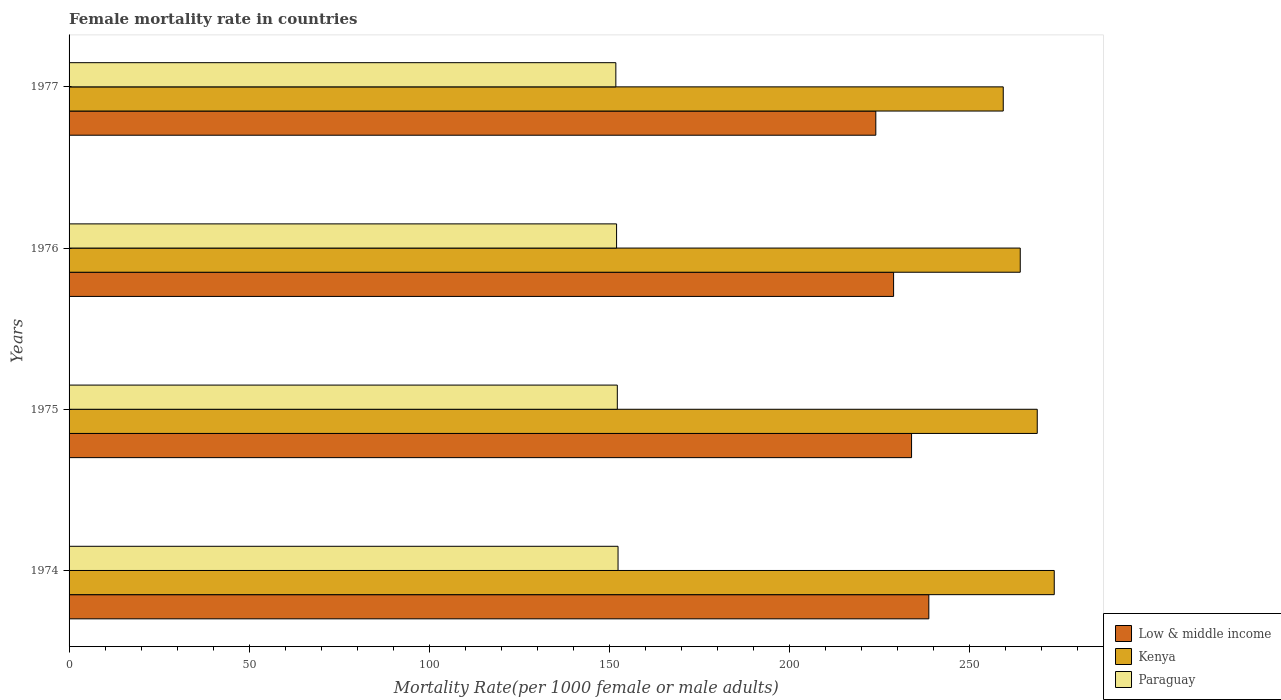How many groups of bars are there?
Offer a very short reply. 4. Are the number of bars on each tick of the Y-axis equal?
Offer a very short reply. Yes. What is the label of the 2nd group of bars from the top?
Offer a terse response. 1976. What is the female mortality rate in Paraguay in 1976?
Provide a succinct answer. 152.01. Across all years, what is the maximum female mortality rate in Paraguay?
Keep it short and to the point. 152.42. Across all years, what is the minimum female mortality rate in Kenya?
Your answer should be very brief. 259.36. In which year was the female mortality rate in Paraguay maximum?
Your response must be concise. 1974. What is the total female mortality rate in Kenya in the graph?
Ensure brevity in your answer.  1065.75. What is the difference between the female mortality rate in Low & middle income in 1976 and that in 1977?
Make the answer very short. 4.94. What is the difference between the female mortality rate in Paraguay in 1977 and the female mortality rate in Low & middle income in 1974?
Offer a very short reply. -86.89. What is the average female mortality rate in Paraguay per year?
Keep it short and to the point. 152.11. In the year 1977, what is the difference between the female mortality rate in Kenya and female mortality rate in Low & middle income?
Offer a very short reply. 35.38. In how many years, is the female mortality rate in Kenya greater than 90 ?
Provide a short and direct response. 4. What is the ratio of the female mortality rate in Low & middle income in 1976 to that in 1977?
Your response must be concise. 1.02. Is the difference between the female mortality rate in Kenya in 1974 and 1977 greater than the difference between the female mortality rate in Low & middle income in 1974 and 1977?
Provide a succinct answer. No. What is the difference between the highest and the second highest female mortality rate in Paraguay?
Offer a very short reply. 0.2. What is the difference between the highest and the lowest female mortality rate in Kenya?
Keep it short and to the point. 14.16. In how many years, is the female mortality rate in Low & middle income greater than the average female mortality rate in Low & middle income taken over all years?
Give a very brief answer. 2. Is the sum of the female mortality rate in Paraguay in 1974 and 1977 greater than the maximum female mortality rate in Low & middle income across all years?
Your answer should be compact. Yes. What does the 1st bar from the top in 1974 represents?
Keep it short and to the point. Paraguay. What does the 2nd bar from the bottom in 1975 represents?
Provide a succinct answer. Kenya. Is it the case that in every year, the sum of the female mortality rate in Low & middle income and female mortality rate in Kenya is greater than the female mortality rate in Paraguay?
Make the answer very short. Yes. How many years are there in the graph?
Ensure brevity in your answer.  4. Are the values on the major ticks of X-axis written in scientific E-notation?
Ensure brevity in your answer.  No. Does the graph contain any zero values?
Make the answer very short. No. Does the graph contain grids?
Keep it short and to the point. No. Where does the legend appear in the graph?
Your answer should be compact. Bottom right. How many legend labels are there?
Your answer should be very brief. 3. What is the title of the graph?
Your response must be concise. Female mortality rate in countries. Does "Curacao" appear as one of the legend labels in the graph?
Provide a succinct answer. No. What is the label or title of the X-axis?
Your answer should be very brief. Mortality Rate(per 1000 female or male adults). What is the label or title of the Y-axis?
Make the answer very short. Years. What is the Mortality Rate(per 1000 female or male adults) in Low & middle income in 1974?
Give a very brief answer. 238.7. What is the Mortality Rate(per 1000 female or male adults) of Kenya in 1974?
Ensure brevity in your answer.  273.52. What is the Mortality Rate(per 1000 female or male adults) in Paraguay in 1974?
Give a very brief answer. 152.42. What is the Mortality Rate(per 1000 female or male adults) of Low & middle income in 1975?
Offer a very short reply. 233.9. What is the Mortality Rate(per 1000 female or male adults) in Kenya in 1975?
Offer a very short reply. 268.8. What is the Mortality Rate(per 1000 female or male adults) in Paraguay in 1975?
Your response must be concise. 152.21. What is the Mortality Rate(per 1000 female or male adults) of Low & middle income in 1976?
Your answer should be compact. 228.92. What is the Mortality Rate(per 1000 female or male adults) of Kenya in 1976?
Provide a succinct answer. 264.08. What is the Mortality Rate(per 1000 female or male adults) in Paraguay in 1976?
Your answer should be very brief. 152.01. What is the Mortality Rate(per 1000 female or male adults) in Low & middle income in 1977?
Your answer should be very brief. 223.98. What is the Mortality Rate(per 1000 female or male adults) of Kenya in 1977?
Offer a very short reply. 259.36. What is the Mortality Rate(per 1000 female or male adults) of Paraguay in 1977?
Offer a very short reply. 151.8. Across all years, what is the maximum Mortality Rate(per 1000 female or male adults) in Low & middle income?
Make the answer very short. 238.7. Across all years, what is the maximum Mortality Rate(per 1000 female or male adults) in Kenya?
Provide a short and direct response. 273.52. Across all years, what is the maximum Mortality Rate(per 1000 female or male adults) in Paraguay?
Keep it short and to the point. 152.42. Across all years, what is the minimum Mortality Rate(per 1000 female or male adults) in Low & middle income?
Your answer should be very brief. 223.98. Across all years, what is the minimum Mortality Rate(per 1000 female or male adults) of Kenya?
Your answer should be very brief. 259.36. Across all years, what is the minimum Mortality Rate(per 1000 female or male adults) in Paraguay?
Offer a terse response. 151.8. What is the total Mortality Rate(per 1000 female or male adults) of Low & middle income in the graph?
Your answer should be compact. 925.49. What is the total Mortality Rate(per 1000 female or male adults) in Kenya in the graph?
Your answer should be compact. 1065.75. What is the total Mortality Rate(per 1000 female or male adults) of Paraguay in the graph?
Give a very brief answer. 608.44. What is the difference between the Mortality Rate(per 1000 female or male adults) in Low & middle income in 1974 and that in 1975?
Provide a succinct answer. 4.8. What is the difference between the Mortality Rate(per 1000 female or male adults) of Kenya in 1974 and that in 1975?
Ensure brevity in your answer.  4.72. What is the difference between the Mortality Rate(per 1000 female or male adults) of Paraguay in 1974 and that in 1975?
Keep it short and to the point. 0.2. What is the difference between the Mortality Rate(per 1000 female or male adults) in Low & middle income in 1974 and that in 1976?
Give a very brief answer. 9.78. What is the difference between the Mortality Rate(per 1000 female or male adults) of Kenya in 1974 and that in 1976?
Your answer should be very brief. 9.44. What is the difference between the Mortality Rate(per 1000 female or male adults) of Paraguay in 1974 and that in 1976?
Your answer should be very brief. 0.41. What is the difference between the Mortality Rate(per 1000 female or male adults) in Low & middle income in 1974 and that in 1977?
Provide a short and direct response. 14.72. What is the difference between the Mortality Rate(per 1000 female or male adults) of Kenya in 1974 and that in 1977?
Provide a succinct answer. 14.16. What is the difference between the Mortality Rate(per 1000 female or male adults) of Paraguay in 1974 and that in 1977?
Your answer should be very brief. 0.61. What is the difference between the Mortality Rate(per 1000 female or male adults) in Low & middle income in 1975 and that in 1976?
Give a very brief answer. 4.99. What is the difference between the Mortality Rate(per 1000 female or male adults) of Kenya in 1975 and that in 1976?
Offer a terse response. 4.72. What is the difference between the Mortality Rate(per 1000 female or male adults) of Paraguay in 1975 and that in 1976?
Offer a very short reply. 0.2. What is the difference between the Mortality Rate(per 1000 female or male adults) in Low & middle income in 1975 and that in 1977?
Keep it short and to the point. 9.93. What is the difference between the Mortality Rate(per 1000 female or male adults) of Kenya in 1975 and that in 1977?
Provide a short and direct response. 9.44. What is the difference between the Mortality Rate(per 1000 female or male adults) of Paraguay in 1975 and that in 1977?
Offer a terse response. 0.41. What is the difference between the Mortality Rate(per 1000 female or male adults) in Low & middle income in 1976 and that in 1977?
Ensure brevity in your answer.  4.94. What is the difference between the Mortality Rate(per 1000 female or male adults) in Kenya in 1976 and that in 1977?
Give a very brief answer. 4.72. What is the difference between the Mortality Rate(per 1000 female or male adults) of Paraguay in 1976 and that in 1977?
Offer a terse response. 0.2. What is the difference between the Mortality Rate(per 1000 female or male adults) of Low & middle income in 1974 and the Mortality Rate(per 1000 female or male adults) of Kenya in 1975?
Your answer should be compact. -30.1. What is the difference between the Mortality Rate(per 1000 female or male adults) of Low & middle income in 1974 and the Mortality Rate(per 1000 female or male adults) of Paraguay in 1975?
Ensure brevity in your answer.  86.49. What is the difference between the Mortality Rate(per 1000 female or male adults) in Kenya in 1974 and the Mortality Rate(per 1000 female or male adults) in Paraguay in 1975?
Provide a short and direct response. 121.31. What is the difference between the Mortality Rate(per 1000 female or male adults) in Low & middle income in 1974 and the Mortality Rate(per 1000 female or male adults) in Kenya in 1976?
Give a very brief answer. -25.38. What is the difference between the Mortality Rate(per 1000 female or male adults) of Low & middle income in 1974 and the Mortality Rate(per 1000 female or male adults) of Paraguay in 1976?
Offer a very short reply. 86.69. What is the difference between the Mortality Rate(per 1000 female or male adults) of Kenya in 1974 and the Mortality Rate(per 1000 female or male adults) of Paraguay in 1976?
Ensure brevity in your answer.  121.51. What is the difference between the Mortality Rate(per 1000 female or male adults) in Low & middle income in 1974 and the Mortality Rate(per 1000 female or male adults) in Kenya in 1977?
Offer a terse response. -20.66. What is the difference between the Mortality Rate(per 1000 female or male adults) of Low & middle income in 1974 and the Mortality Rate(per 1000 female or male adults) of Paraguay in 1977?
Provide a short and direct response. 86.89. What is the difference between the Mortality Rate(per 1000 female or male adults) in Kenya in 1974 and the Mortality Rate(per 1000 female or male adults) in Paraguay in 1977?
Make the answer very short. 121.71. What is the difference between the Mortality Rate(per 1000 female or male adults) in Low & middle income in 1975 and the Mortality Rate(per 1000 female or male adults) in Kenya in 1976?
Provide a succinct answer. -30.18. What is the difference between the Mortality Rate(per 1000 female or male adults) of Low & middle income in 1975 and the Mortality Rate(per 1000 female or male adults) of Paraguay in 1976?
Your answer should be very brief. 81.89. What is the difference between the Mortality Rate(per 1000 female or male adults) of Kenya in 1975 and the Mortality Rate(per 1000 female or male adults) of Paraguay in 1976?
Provide a short and direct response. 116.79. What is the difference between the Mortality Rate(per 1000 female or male adults) of Low & middle income in 1975 and the Mortality Rate(per 1000 female or male adults) of Kenya in 1977?
Your answer should be compact. -25.46. What is the difference between the Mortality Rate(per 1000 female or male adults) of Low & middle income in 1975 and the Mortality Rate(per 1000 female or male adults) of Paraguay in 1977?
Offer a terse response. 82.1. What is the difference between the Mortality Rate(per 1000 female or male adults) in Kenya in 1975 and the Mortality Rate(per 1000 female or male adults) in Paraguay in 1977?
Offer a very short reply. 116.99. What is the difference between the Mortality Rate(per 1000 female or male adults) of Low & middle income in 1976 and the Mortality Rate(per 1000 female or male adults) of Kenya in 1977?
Your response must be concise. -30.44. What is the difference between the Mortality Rate(per 1000 female or male adults) of Low & middle income in 1976 and the Mortality Rate(per 1000 female or male adults) of Paraguay in 1977?
Offer a very short reply. 77.11. What is the difference between the Mortality Rate(per 1000 female or male adults) of Kenya in 1976 and the Mortality Rate(per 1000 female or male adults) of Paraguay in 1977?
Your response must be concise. 112.28. What is the average Mortality Rate(per 1000 female or male adults) of Low & middle income per year?
Your response must be concise. 231.37. What is the average Mortality Rate(per 1000 female or male adults) of Kenya per year?
Your answer should be very brief. 266.44. What is the average Mortality Rate(per 1000 female or male adults) in Paraguay per year?
Ensure brevity in your answer.  152.11. In the year 1974, what is the difference between the Mortality Rate(per 1000 female or male adults) of Low & middle income and Mortality Rate(per 1000 female or male adults) of Kenya?
Ensure brevity in your answer.  -34.82. In the year 1974, what is the difference between the Mortality Rate(per 1000 female or male adults) in Low & middle income and Mortality Rate(per 1000 female or male adults) in Paraguay?
Give a very brief answer. 86.28. In the year 1974, what is the difference between the Mortality Rate(per 1000 female or male adults) of Kenya and Mortality Rate(per 1000 female or male adults) of Paraguay?
Provide a short and direct response. 121.1. In the year 1975, what is the difference between the Mortality Rate(per 1000 female or male adults) of Low & middle income and Mortality Rate(per 1000 female or male adults) of Kenya?
Provide a short and direct response. -34.9. In the year 1975, what is the difference between the Mortality Rate(per 1000 female or male adults) of Low & middle income and Mortality Rate(per 1000 female or male adults) of Paraguay?
Offer a very short reply. 81.69. In the year 1975, what is the difference between the Mortality Rate(per 1000 female or male adults) in Kenya and Mortality Rate(per 1000 female or male adults) in Paraguay?
Your answer should be compact. 116.59. In the year 1976, what is the difference between the Mortality Rate(per 1000 female or male adults) in Low & middle income and Mortality Rate(per 1000 female or male adults) in Kenya?
Your response must be concise. -35.16. In the year 1976, what is the difference between the Mortality Rate(per 1000 female or male adults) of Low & middle income and Mortality Rate(per 1000 female or male adults) of Paraguay?
Give a very brief answer. 76.91. In the year 1976, what is the difference between the Mortality Rate(per 1000 female or male adults) of Kenya and Mortality Rate(per 1000 female or male adults) of Paraguay?
Your answer should be compact. 112.07. In the year 1977, what is the difference between the Mortality Rate(per 1000 female or male adults) of Low & middle income and Mortality Rate(per 1000 female or male adults) of Kenya?
Your response must be concise. -35.38. In the year 1977, what is the difference between the Mortality Rate(per 1000 female or male adults) of Low & middle income and Mortality Rate(per 1000 female or male adults) of Paraguay?
Make the answer very short. 72.17. In the year 1977, what is the difference between the Mortality Rate(per 1000 female or male adults) of Kenya and Mortality Rate(per 1000 female or male adults) of Paraguay?
Your answer should be very brief. 107.56. What is the ratio of the Mortality Rate(per 1000 female or male adults) in Low & middle income in 1974 to that in 1975?
Ensure brevity in your answer.  1.02. What is the ratio of the Mortality Rate(per 1000 female or male adults) in Kenya in 1974 to that in 1975?
Keep it short and to the point. 1.02. What is the ratio of the Mortality Rate(per 1000 female or male adults) of Paraguay in 1974 to that in 1975?
Offer a very short reply. 1. What is the ratio of the Mortality Rate(per 1000 female or male adults) of Low & middle income in 1974 to that in 1976?
Offer a very short reply. 1.04. What is the ratio of the Mortality Rate(per 1000 female or male adults) of Kenya in 1974 to that in 1976?
Your answer should be compact. 1.04. What is the ratio of the Mortality Rate(per 1000 female or male adults) in Low & middle income in 1974 to that in 1977?
Your answer should be compact. 1.07. What is the ratio of the Mortality Rate(per 1000 female or male adults) of Kenya in 1974 to that in 1977?
Offer a very short reply. 1.05. What is the ratio of the Mortality Rate(per 1000 female or male adults) in Paraguay in 1974 to that in 1977?
Your answer should be very brief. 1. What is the ratio of the Mortality Rate(per 1000 female or male adults) of Low & middle income in 1975 to that in 1976?
Make the answer very short. 1.02. What is the ratio of the Mortality Rate(per 1000 female or male adults) in Kenya in 1975 to that in 1976?
Ensure brevity in your answer.  1.02. What is the ratio of the Mortality Rate(per 1000 female or male adults) of Low & middle income in 1975 to that in 1977?
Give a very brief answer. 1.04. What is the ratio of the Mortality Rate(per 1000 female or male adults) in Kenya in 1975 to that in 1977?
Ensure brevity in your answer.  1.04. What is the ratio of the Mortality Rate(per 1000 female or male adults) of Paraguay in 1975 to that in 1977?
Keep it short and to the point. 1. What is the ratio of the Mortality Rate(per 1000 female or male adults) in Kenya in 1976 to that in 1977?
Your answer should be compact. 1.02. What is the ratio of the Mortality Rate(per 1000 female or male adults) in Paraguay in 1976 to that in 1977?
Your answer should be compact. 1. What is the difference between the highest and the second highest Mortality Rate(per 1000 female or male adults) of Low & middle income?
Your answer should be compact. 4.8. What is the difference between the highest and the second highest Mortality Rate(per 1000 female or male adults) in Kenya?
Your answer should be very brief. 4.72. What is the difference between the highest and the second highest Mortality Rate(per 1000 female or male adults) in Paraguay?
Provide a short and direct response. 0.2. What is the difference between the highest and the lowest Mortality Rate(per 1000 female or male adults) in Low & middle income?
Your response must be concise. 14.72. What is the difference between the highest and the lowest Mortality Rate(per 1000 female or male adults) of Kenya?
Your answer should be very brief. 14.16. What is the difference between the highest and the lowest Mortality Rate(per 1000 female or male adults) in Paraguay?
Provide a succinct answer. 0.61. 